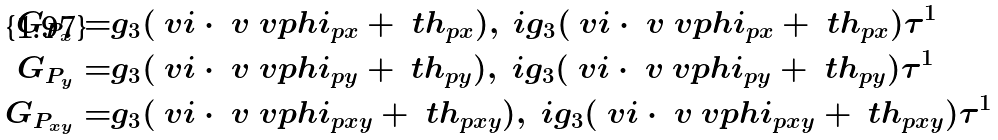Convert formula to latex. <formula><loc_0><loc_0><loc_500><loc_500>G _ { P _ { x } } = & g _ { 3 } ( \ v i \cdot \ v \ v p h i _ { p x } + \ t h _ { p x } ) , \ i g _ { 3 } ( \ v i \cdot \ v \ v p h i _ { p x } + \ t h _ { p x } ) \tau ^ { 1 } \\ G _ { P _ { y } } = & g _ { 3 } ( \ v i \cdot \ v \ v p h i _ { p y } + \ t h _ { p y } ) , \ i g _ { 3 } ( \ v i \cdot \ v \ v p h i _ { p y } + \ t h _ { p y } ) \tau ^ { 1 } \\ G _ { P _ { x y } } = & g _ { 3 } ( \ v i \cdot \ v \ v p h i _ { p x y } + \ t h _ { p x y } ) , \ i g _ { 3 } ( \ v i \cdot \ v \ v p h i _ { p x y } + \ t h _ { p x y } ) \tau ^ { 1 }</formula> 